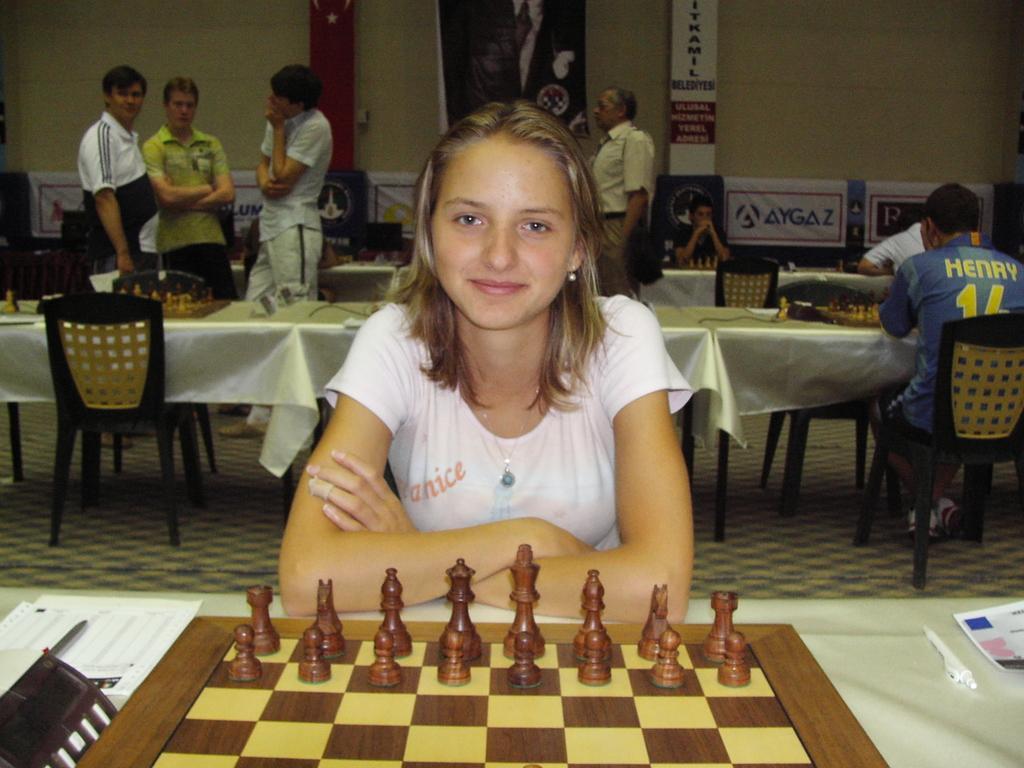Describe this image in one or two sentences. In this image there is a girl sitting in chair and playing the chess game and in table there are chess board , chess coins , paper, pen and in back ground there is table, chairs , group of people standing ,banner, cables. 